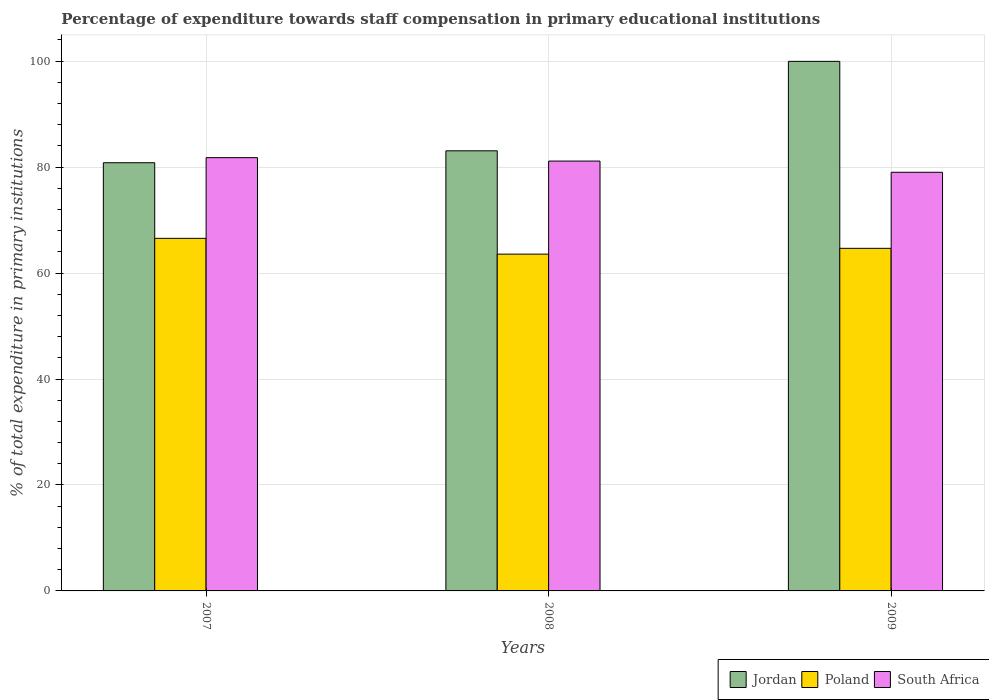How many groups of bars are there?
Offer a terse response. 3. How many bars are there on the 2nd tick from the left?
Offer a very short reply. 3. What is the percentage of expenditure towards staff compensation in South Africa in 2009?
Offer a very short reply. 79.03. Across all years, what is the maximum percentage of expenditure towards staff compensation in Poland?
Provide a succinct answer. 66.55. Across all years, what is the minimum percentage of expenditure towards staff compensation in Jordan?
Provide a succinct answer. 80.83. In which year was the percentage of expenditure towards staff compensation in South Africa minimum?
Ensure brevity in your answer.  2009. What is the total percentage of expenditure towards staff compensation in Poland in the graph?
Offer a very short reply. 194.8. What is the difference between the percentage of expenditure towards staff compensation in South Africa in 2008 and that in 2009?
Your answer should be compact. 2.12. What is the difference between the percentage of expenditure towards staff compensation in Jordan in 2007 and the percentage of expenditure towards staff compensation in Poland in 2009?
Give a very brief answer. 16.16. What is the average percentage of expenditure towards staff compensation in Poland per year?
Give a very brief answer. 64.93. In the year 2008, what is the difference between the percentage of expenditure towards staff compensation in Jordan and percentage of expenditure towards staff compensation in South Africa?
Make the answer very short. 1.93. In how many years, is the percentage of expenditure towards staff compensation in South Africa greater than 52 %?
Give a very brief answer. 3. What is the ratio of the percentage of expenditure towards staff compensation in Poland in 2008 to that in 2009?
Your answer should be compact. 0.98. Is the difference between the percentage of expenditure towards staff compensation in Jordan in 2008 and 2009 greater than the difference between the percentage of expenditure towards staff compensation in South Africa in 2008 and 2009?
Your answer should be very brief. No. What is the difference between the highest and the second highest percentage of expenditure towards staff compensation in South Africa?
Provide a succinct answer. 0.64. What is the difference between the highest and the lowest percentage of expenditure towards staff compensation in Poland?
Keep it short and to the point. 2.98. In how many years, is the percentage of expenditure towards staff compensation in South Africa greater than the average percentage of expenditure towards staff compensation in South Africa taken over all years?
Your answer should be compact. 2. What does the 1st bar from the left in 2009 represents?
Give a very brief answer. Jordan. What does the 1st bar from the right in 2008 represents?
Make the answer very short. South Africa. Are all the bars in the graph horizontal?
Give a very brief answer. No. What is the difference between two consecutive major ticks on the Y-axis?
Offer a very short reply. 20. Does the graph contain any zero values?
Your answer should be very brief. No. Does the graph contain grids?
Your response must be concise. Yes. How many legend labels are there?
Your answer should be very brief. 3. What is the title of the graph?
Offer a very short reply. Percentage of expenditure towards staff compensation in primary educational institutions. What is the label or title of the Y-axis?
Give a very brief answer. % of total expenditure in primary institutions. What is the % of total expenditure in primary institutions of Jordan in 2007?
Offer a terse response. 80.83. What is the % of total expenditure in primary institutions of Poland in 2007?
Offer a terse response. 66.55. What is the % of total expenditure in primary institutions in South Africa in 2007?
Give a very brief answer. 81.79. What is the % of total expenditure in primary institutions of Jordan in 2008?
Offer a terse response. 83.08. What is the % of total expenditure in primary institutions in Poland in 2008?
Provide a short and direct response. 63.57. What is the % of total expenditure in primary institutions of South Africa in 2008?
Make the answer very short. 81.14. What is the % of total expenditure in primary institutions of Jordan in 2009?
Provide a succinct answer. 99.96. What is the % of total expenditure in primary institutions in Poland in 2009?
Your answer should be very brief. 64.67. What is the % of total expenditure in primary institutions in South Africa in 2009?
Your response must be concise. 79.03. Across all years, what is the maximum % of total expenditure in primary institutions of Jordan?
Give a very brief answer. 99.96. Across all years, what is the maximum % of total expenditure in primary institutions of Poland?
Provide a short and direct response. 66.55. Across all years, what is the maximum % of total expenditure in primary institutions in South Africa?
Keep it short and to the point. 81.79. Across all years, what is the minimum % of total expenditure in primary institutions in Jordan?
Your response must be concise. 80.83. Across all years, what is the minimum % of total expenditure in primary institutions of Poland?
Offer a very short reply. 63.57. Across all years, what is the minimum % of total expenditure in primary institutions in South Africa?
Provide a short and direct response. 79.03. What is the total % of total expenditure in primary institutions in Jordan in the graph?
Your answer should be compact. 263.87. What is the total % of total expenditure in primary institutions in Poland in the graph?
Provide a succinct answer. 194.8. What is the total % of total expenditure in primary institutions in South Africa in the graph?
Give a very brief answer. 241.95. What is the difference between the % of total expenditure in primary institutions in Jordan in 2007 and that in 2008?
Ensure brevity in your answer.  -2.25. What is the difference between the % of total expenditure in primary institutions of Poland in 2007 and that in 2008?
Your answer should be compact. 2.98. What is the difference between the % of total expenditure in primary institutions in South Africa in 2007 and that in 2008?
Your response must be concise. 0.64. What is the difference between the % of total expenditure in primary institutions in Jordan in 2007 and that in 2009?
Your response must be concise. -19.14. What is the difference between the % of total expenditure in primary institutions of Poland in 2007 and that in 2009?
Provide a short and direct response. 1.89. What is the difference between the % of total expenditure in primary institutions in South Africa in 2007 and that in 2009?
Offer a very short reply. 2.76. What is the difference between the % of total expenditure in primary institutions of Jordan in 2008 and that in 2009?
Make the answer very short. -16.89. What is the difference between the % of total expenditure in primary institutions in Poland in 2008 and that in 2009?
Offer a terse response. -1.09. What is the difference between the % of total expenditure in primary institutions in South Africa in 2008 and that in 2009?
Your response must be concise. 2.12. What is the difference between the % of total expenditure in primary institutions of Jordan in 2007 and the % of total expenditure in primary institutions of Poland in 2008?
Your answer should be compact. 17.25. What is the difference between the % of total expenditure in primary institutions of Jordan in 2007 and the % of total expenditure in primary institutions of South Africa in 2008?
Provide a succinct answer. -0.31. What is the difference between the % of total expenditure in primary institutions of Poland in 2007 and the % of total expenditure in primary institutions of South Africa in 2008?
Provide a short and direct response. -14.59. What is the difference between the % of total expenditure in primary institutions of Jordan in 2007 and the % of total expenditure in primary institutions of Poland in 2009?
Offer a very short reply. 16.16. What is the difference between the % of total expenditure in primary institutions in Jordan in 2007 and the % of total expenditure in primary institutions in South Africa in 2009?
Give a very brief answer. 1.8. What is the difference between the % of total expenditure in primary institutions of Poland in 2007 and the % of total expenditure in primary institutions of South Africa in 2009?
Offer a terse response. -12.47. What is the difference between the % of total expenditure in primary institutions of Jordan in 2008 and the % of total expenditure in primary institutions of Poland in 2009?
Offer a very short reply. 18.41. What is the difference between the % of total expenditure in primary institutions of Jordan in 2008 and the % of total expenditure in primary institutions of South Africa in 2009?
Provide a short and direct response. 4.05. What is the difference between the % of total expenditure in primary institutions in Poland in 2008 and the % of total expenditure in primary institutions in South Africa in 2009?
Keep it short and to the point. -15.45. What is the average % of total expenditure in primary institutions of Jordan per year?
Your response must be concise. 87.96. What is the average % of total expenditure in primary institutions in Poland per year?
Make the answer very short. 64.93. What is the average % of total expenditure in primary institutions of South Africa per year?
Offer a terse response. 80.65. In the year 2007, what is the difference between the % of total expenditure in primary institutions in Jordan and % of total expenditure in primary institutions in Poland?
Your answer should be very brief. 14.28. In the year 2007, what is the difference between the % of total expenditure in primary institutions of Jordan and % of total expenditure in primary institutions of South Africa?
Provide a short and direct response. -0.96. In the year 2007, what is the difference between the % of total expenditure in primary institutions of Poland and % of total expenditure in primary institutions of South Africa?
Your response must be concise. -15.23. In the year 2008, what is the difference between the % of total expenditure in primary institutions of Jordan and % of total expenditure in primary institutions of Poland?
Your answer should be very brief. 19.5. In the year 2008, what is the difference between the % of total expenditure in primary institutions in Jordan and % of total expenditure in primary institutions in South Africa?
Your answer should be very brief. 1.93. In the year 2008, what is the difference between the % of total expenditure in primary institutions of Poland and % of total expenditure in primary institutions of South Africa?
Your answer should be very brief. -17.57. In the year 2009, what is the difference between the % of total expenditure in primary institutions in Jordan and % of total expenditure in primary institutions in Poland?
Your response must be concise. 35.3. In the year 2009, what is the difference between the % of total expenditure in primary institutions of Jordan and % of total expenditure in primary institutions of South Africa?
Make the answer very short. 20.94. In the year 2009, what is the difference between the % of total expenditure in primary institutions of Poland and % of total expenditure in primary institutions of South Africa?
Offer a very short reply. -14.36. What is the ratio of the % of total expenditure in primary institutions in Poland in 2007 to that in 2008?
Provide a short and direct response. 1.05. What is the ratio of the % of total expenditure in primary institutions of South Africa in 2007 to that in 2008?
Make the answer very short. 1.01. What is the ratio of the % of total expenditure in primary institutions in Jordan in 2007 to that in 2009?
Your response must be concise. 0.81. What is the ratio of the % of total expenditure in primary institutions in Poland in 2007 to that in 2009?
Make the answer very short. 1.03. What is the ratio of the % of total expenditure in primary institutions of South Africa in 2007 to that in 2009?
Make the answer very short. 1.03. What is the ratio of the % of total expenditure in primary institutions of Jordan in 2008 to that in 2009?
Make the answer very short. 0.83. What is the ratio of the % of total expenditure in primary institutions of Poland in 2008 to that in 2009?
Ensure brevity in your answer.  0.98. What is the ratio of the % of total expenditure in primary institutions in South Africa in 2008 to that in 2009?
Ensure brevity in your answer.  1.03. What is the difference between the highest and the second highest % of total expenditure in primary institutions in Jordan?
Provide a succinct answer. 16.89. What is the difference between the highest and the second highest % of total expenditure in primary institutions in Poland?
Offer a terse response. 1.89. What is the difference between the highest and the second highest % of total expenditure in primary institutions of South Africa?
Keep it short and to the point. 0.64. What is the difference between the highest and the lowest % of total expenditure in primary institutions of Jordan?
Offer a very short reply. 19.14. What is the difference between the highest and the lowest % of total expenditure in primary institutions in Poland?
Give a very brief answer. 2.98. What is the difference between the highest and the lowest % of total expenditure in primary institutions of South Africa?
Ensure brevity in your answer.  2.76. 